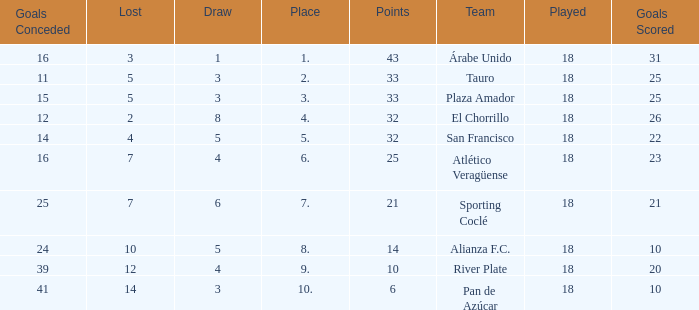Would you be able to parse every entry in this table? {'header': ['Goals Conceded', 'Lost', 'Draw', 'Place', 'Points', 'Team', 'Played', 'Goals Scored'], 'rows': [['16', '3', '1', '1.', '43', 'Árabe Unido', '18', '31'], ['11', '5', '3', '2.', '33', 'Tauro', '18', '25'], ['15', '5', '3', '3.', '33', 'Plaza Amador', '18', '25'], ['12', '2', '8', '4.', '32', 'El Chorrillo', '18', '26'], ['14', '4', '5', '5.', '32', 'San Francisco', '18', '22'], ['16', '7', '4', '6.', '25', 'Atlético Veragüense', '18', '23'], ['25', '7', '6', '7.', '21', 'Sporting Coclé', '18', '21'], ['24', '10', '5', '8.', '14', 'Alianza F.C.', '18', '10'], ['39', '12', '4', '9.', '10', 'River Plate', '18', '20'], ['41', '14', '3', '10.', '6', 'Pan de Azúcar', '18', '10']]} How many goals were conceded by the team with more than 21 points more than 5 draws and less than 18 games played? None. 